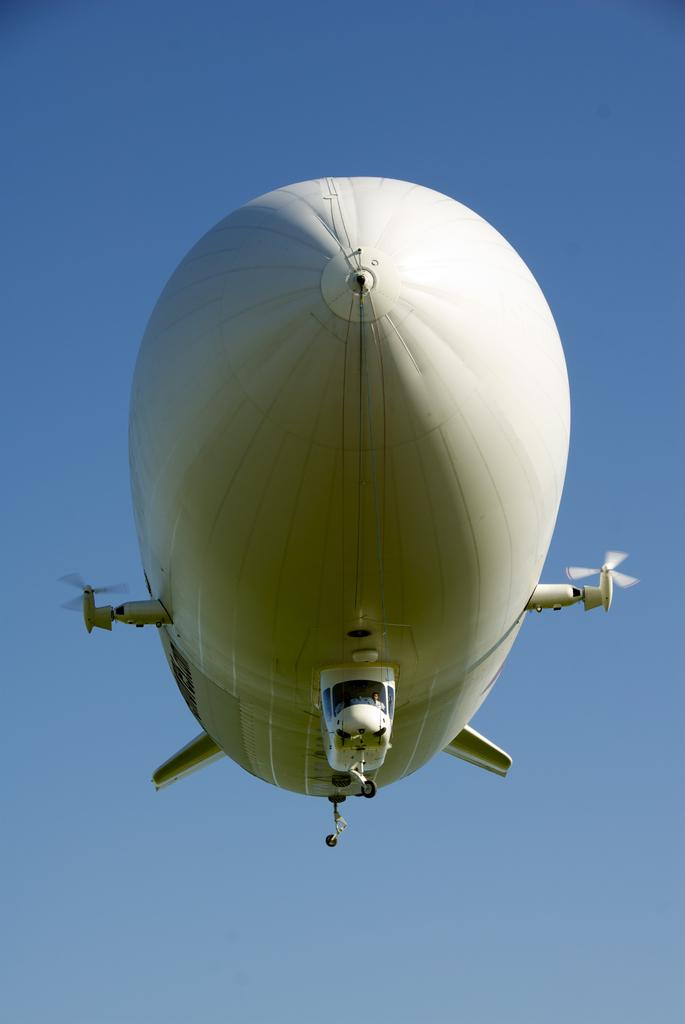What is the main subject of the picture? The main subject of the picture is an airship. What can be observed about the sky in the image? The sky is blue in the image. Can you tell me how many rats are climbing on the airship in the image? There are no rats present in the image; it features an airship and a blue sky. What type of farming equipment is visible in the image? There is no farming equipment present in the image. 